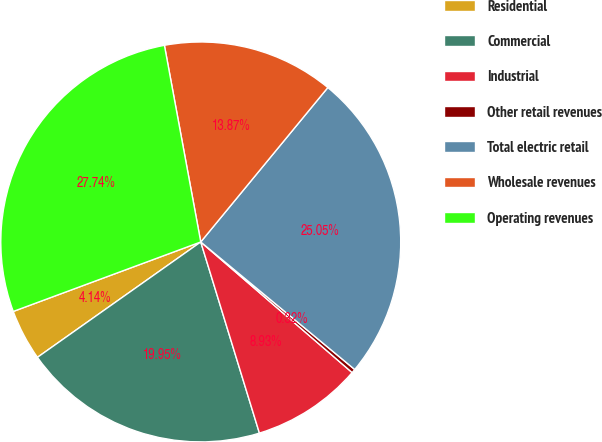Convert chart to OTSL. <chart><loc_0><loc_0><loc_500><loc_500><pie_chart><fcel>Residential<fcel>Commercial<fcel>Industrial<fcel>Other retail revenues<fcel>Total electric retail<fcel>Wholesale revenues<fcel>Operating revenues<nl><fcel>4.14%<fcel>19.95%<fcel>8.93%<fcel>0.32%<fcel>25.05%<fcel>13.87%<fcel>27.74%<nl></chart> 